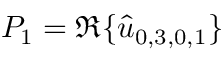Convert formula to latex. <formula><loc_0><loc_0><loc_500><loc_500>P _ { 1 } = \Re \{ \hat { u } _ { 0 , 3 , 0 , 1 } \}</formula> 